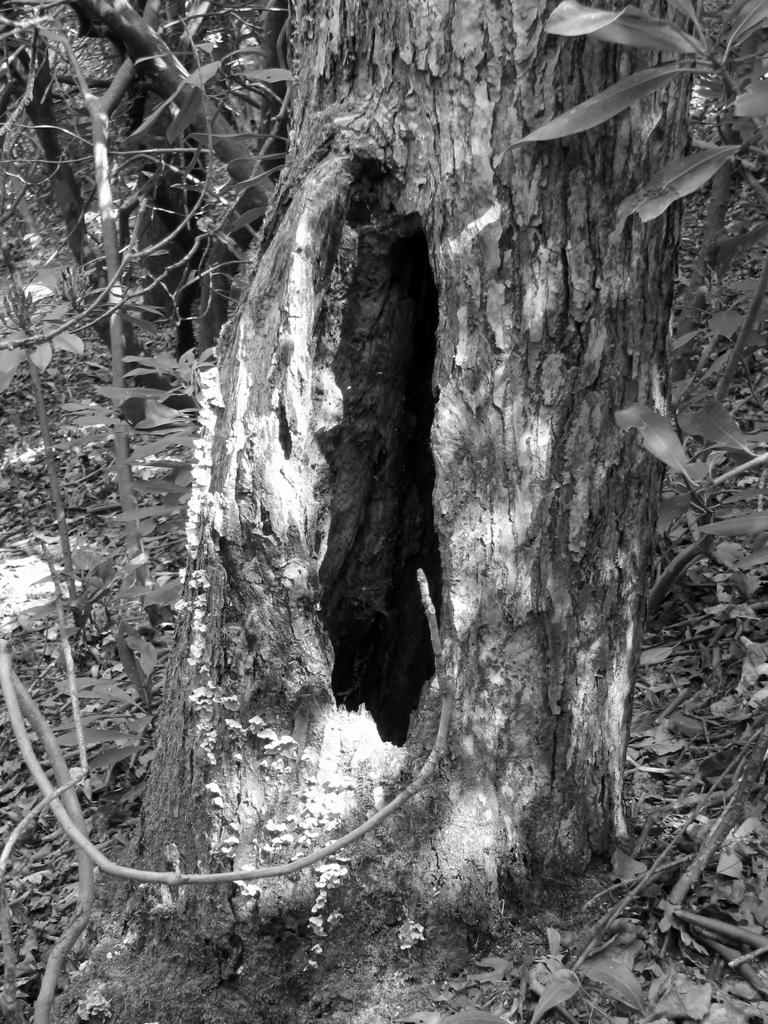What is the color scheme of the image? The image is black and white. What can be seen in the tree trunk in the image? There is a hole in a tree trunk in the image. What type of vegetation is on the left side of the image? There are plants on the left side of the image. What type of vegetation is on the right side of the image? There are plants on the right side of the image. Can you see any snails crawling on the plants in the image? There are no snails visible in the image; it only features plants and a tree trunk with a hole. What type of camp can be seen in the image? There is no camp present in the image; it only features plants, a tree trunk, and a hole. 